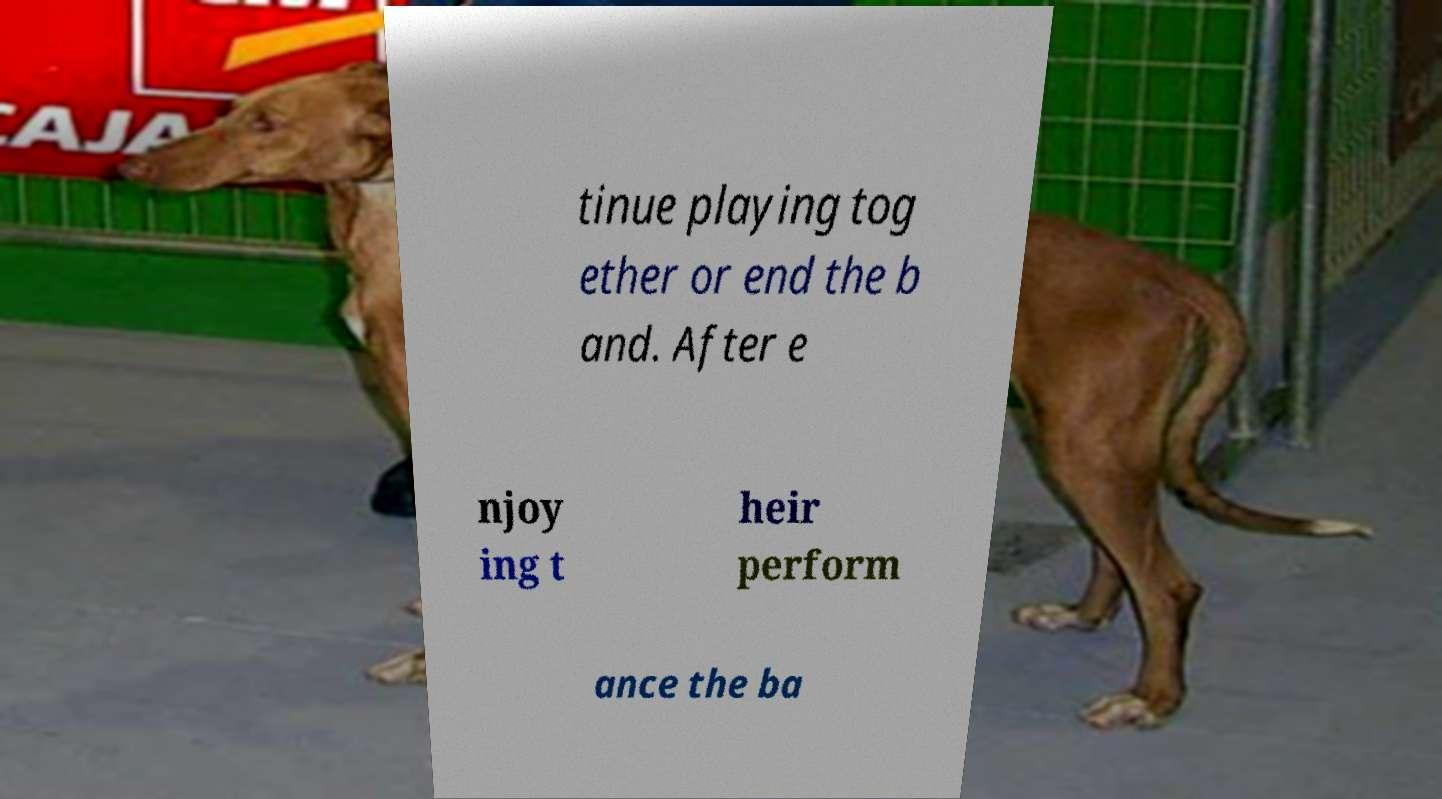Can you read and provide the text displayed in the image?This photo seems to have some interesting text. Can you extract and type it out for me? tinue playing tog ether or end the b and. After e njoy ing t heir perform ance the ba 